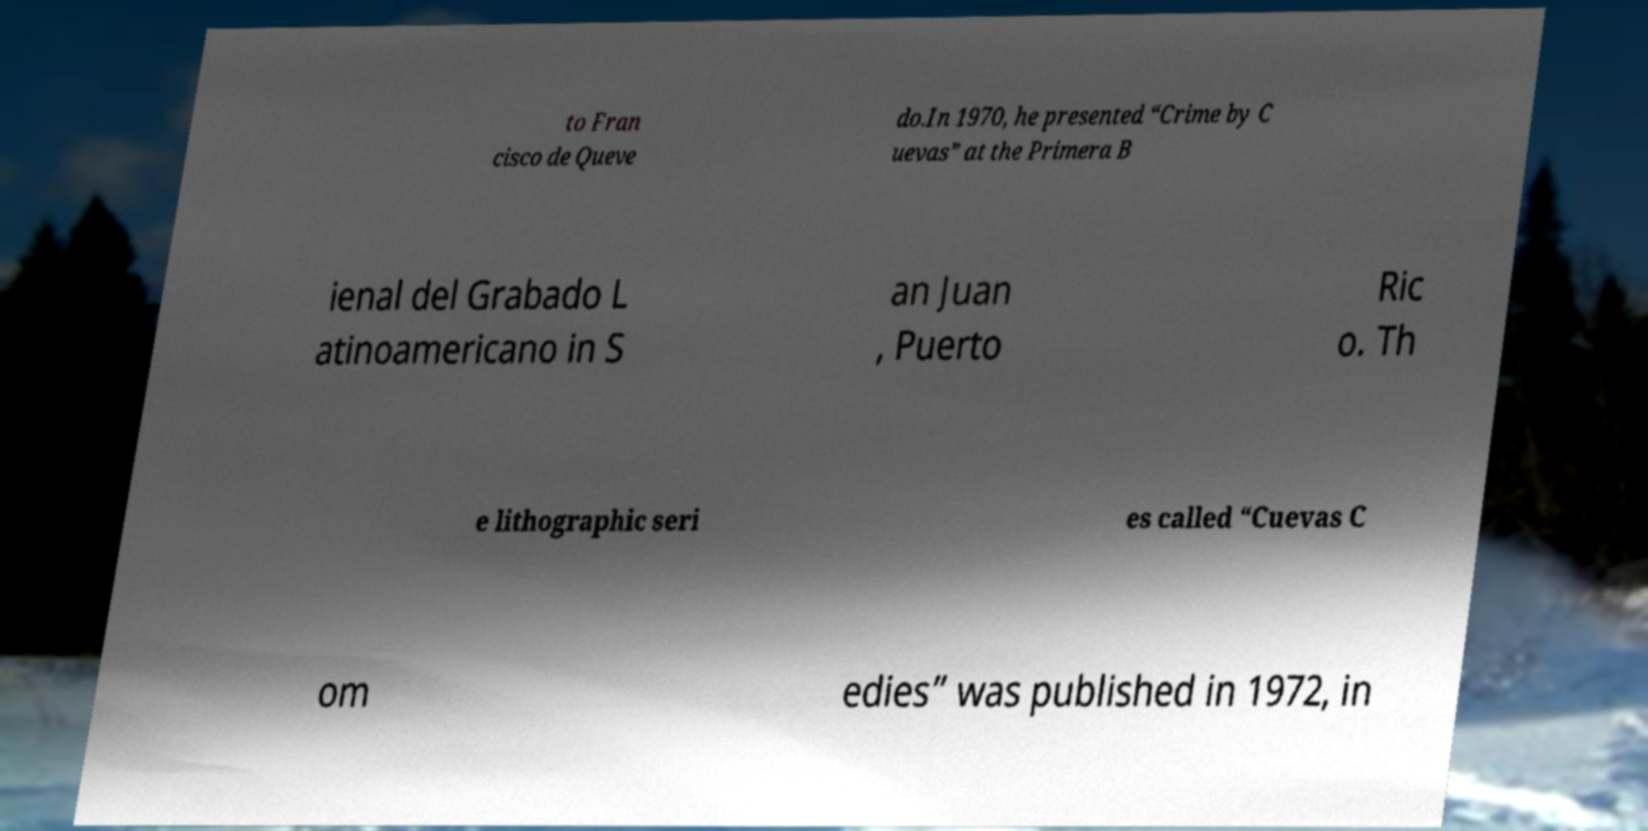What messages or text are displayed in this image? I need them in a readable, typed format. to Fran cisco de Queve do.In 1970, he presented “Crime by C uevas” at the Primera B ienal del Grabado L atinoamericano in S an Juan , Puerto Ric o. Th e lithographic seri es called “Cuevas C om edies” was published in 1972, in 